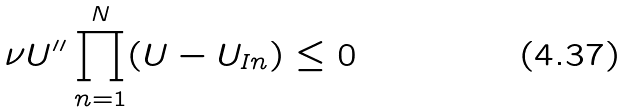<formula> <loc_0><loc_0><loc_500><loc_500>\nu U ^ { \prime \prime } \prod _ { n = 1 } ^ { N } ( U - U _ { I n } ) \leq 0</formula> 